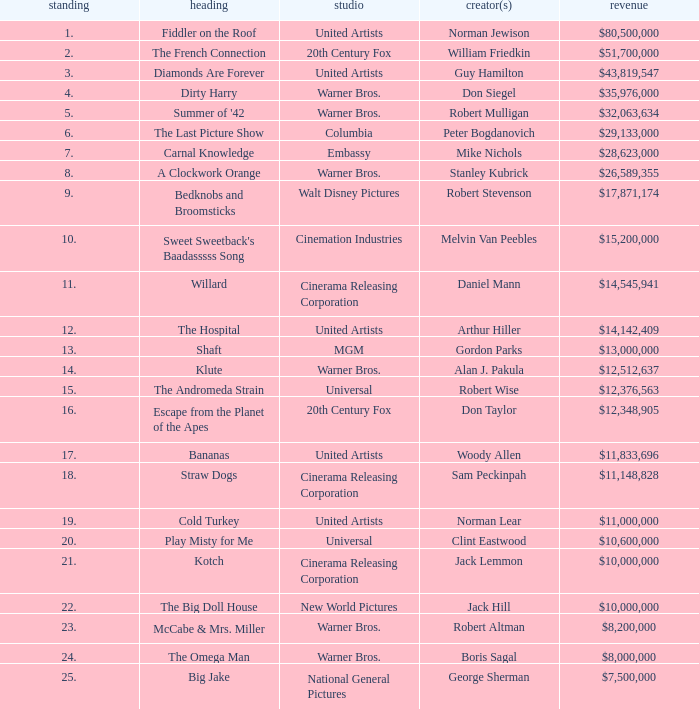What rank has a gross of $35,976,000? 4.0. Parse the full table. {'header': ['standing', 'heading', 'studio', 'creator(s)', 'revenue'], 'rows': [['1.', 'Fiddler on the Roof', 'United Artists', 'Norman Jewison', '$80,500,000'], ['2.', 'The French Connection', '20th Century Fox', 'William Friedkin', '$51,700,000'], ['3.', 'Diamonds Are Forever', 'United Artists', 'Guy Hamilton', '$43,819,547'], ['4.', 'Dirty Harry', 'Warner Bros.', 'Don Siegel', '$35,976,000'], ['5.', "Summer of '42", 'Warner Bros.', 'Robert Mulligan', '$32,063,634'], ['6.', 'The Last Picture Show', 'Columbia', 'Peter Bogdanovich', '$29,133,000'], ['7.', 'Carnal Knowledge', 'Embassy', 'Mike Nichols', '$28,623,000'], ['8.', 'A Clockwork Orange', 'Warner Bros.', 'Stanley Kubrick', '$26,589,355'], ['9.', 'Bedknobs and Broomsticks', 'Walt Disney Pictures', 'Robert Stevenson', '$17,871,174'], ['10.', "Sweet Sweetback's Baadasssss Song", 'Cinemation Industries', 'Melvin Van Peebles', '$15,200,000'], ['11.', 'Willard', 'Cinerama Releasing Corporation', 'Daniel Mann', '$14,545,941'], ['12.', 'The Hospital', 'United Artists', 'Arthur Hiller', '$14,142,409'], ['13.', 'Shaft', 'MGM', 'Gordon Parks', '$13,000,000'], ['14.', 'Klute', 'Warner Bros.', 'Alan J. Pakula', '$12,512,637'], ['15.', 'The Andromeda Strain', 'Universal', 'Robert Wise', '$12,376,563'], ['16.', 'Escape from the Planet of the Apes', '20th Century Fox', 'Don Taylor', '$12,348,905'], ['17.', 'Bananas', 'United Artists', 'Woody Allen', '$11,833,696'], ['18.', 'Straw Dogs', 'Cinerama Releasing Corporation', 'Sam Peckinpah', '$11,148,828'], ['19.', 'Cold Turkey', 'United Artists', 'Norman Lear', '$11,000,000'], ['20.', 'Play Misty for Me', 'Universal', 'Clint Eastwood', '$10,600,000'], ['21.', 'Kotch', 'Cinerama Releasing Corporation', 'Jack Lemmon', '$10,000,000'], ['22.', 'The Big Doll House', 'New World Pictures', 'Jack Hill', '$10,000,000'], ['23.', 'McCabe & Mrs. Miller', 'Warner Bros.', 'Robert Altman', '$8,200,000'], ['24.', 'The Omega Man', 'Warner Bros.', 'Boris Sagal', '$8,000,000'], ['25.', 'Big Jake', 'National General Pictures', 'George Sherman', '$7,500,000']]} 